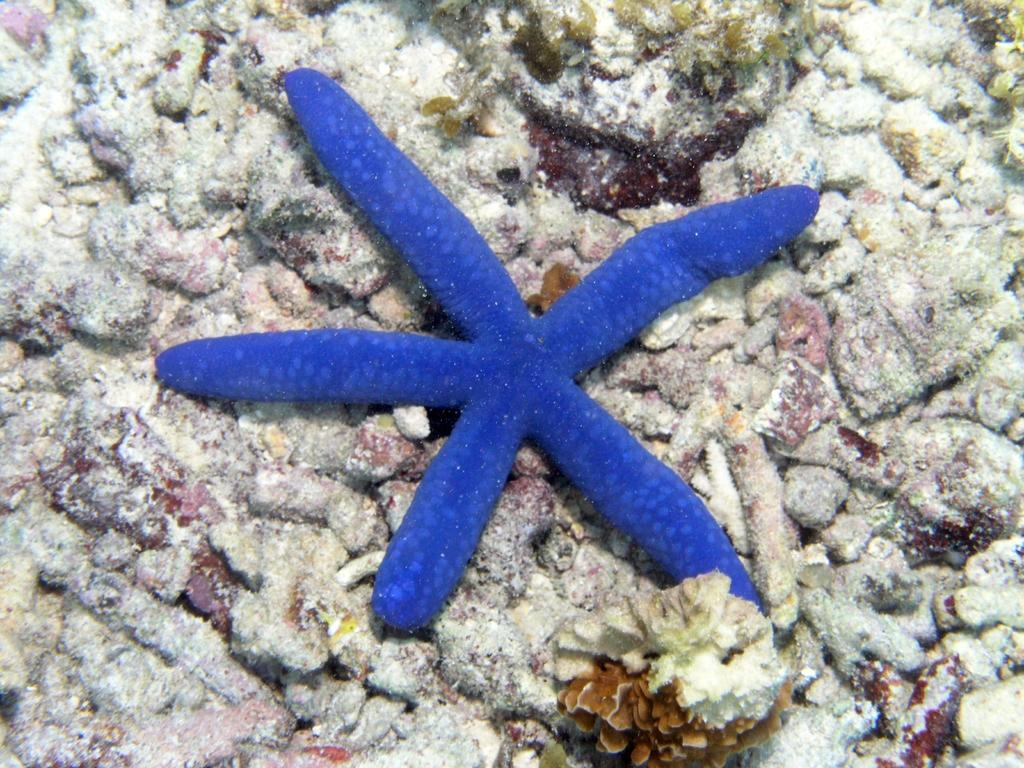What type of animal can be seen in the image? There is an aquatic animal in the image. What color is the aquatic animal? The aquatic animal is blue in color. What can be seen in the background of the image? There are stones visible in the background of the image. What type of cloth is draped over the aquatic animal in the image? There is no cloth present in the image; it features an aquatic animal and stones in the background. 